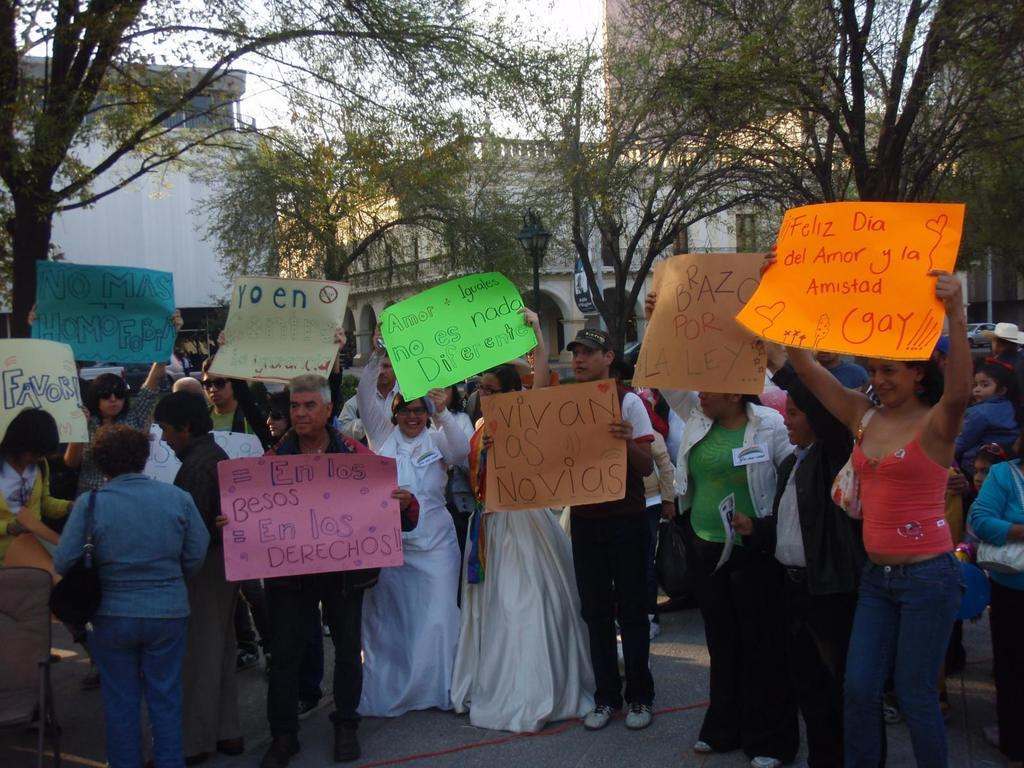What are the people in the image doing? The people in the image are standing in the center and holding boards in their hands. What can be seen in the background of the image? There are trees, buildings, and the sky visible in the background of the image. What type of birds can be seen flying in the garden in the image? There is no garden or birds present in the image. What type of business is being conducted by the people in the image? The image does not provide any information about the purpose or nature of the activity being conducted by the people holding boards. 